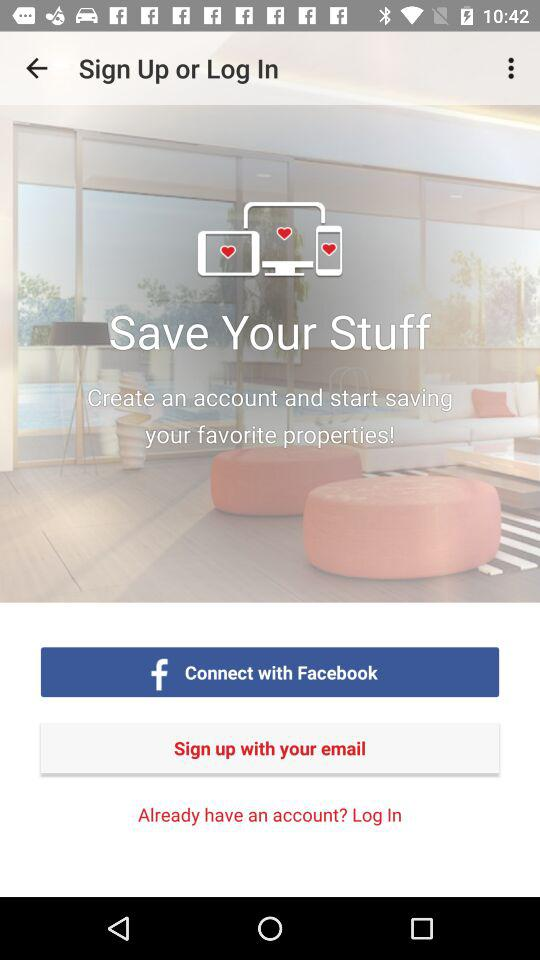What applications can be used to sign up? The application "Facebook" can be used to sign up. 